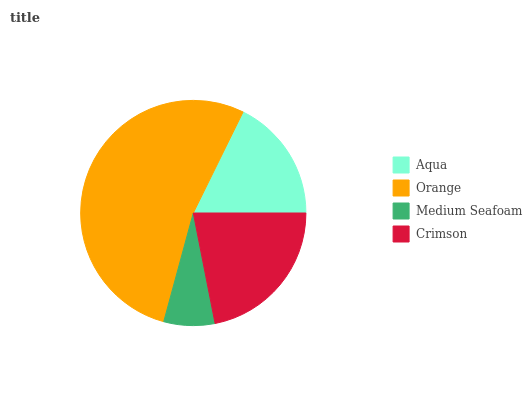Is Medium Seafoam the minimum?
Answer yes or no. Yes. Is Orange the maximum?
Answer yes or no. Yes. Is Orange the minimum?
Answer yes or no. No. Is Medium Seafoam the maximum?
Answer yes or no. No. Is Orange greater than Medium Seafoam?
Answer yes or no. Yes. Is Medium Seafoam less than Orange?
Answer yes or no. Yes. Is Medium Seafoam greater than Orange?
Answer yes or no. No. Is Orange less than Medium Seafoam?
Answer yes or no. No. Is Crimson the high median?
Answer yes or no. Yes. Is Aqua the low median?
Answer yes or no. Yes. Is Orange the high median?
Answer yes or no. No. Is Crimson the low median?
Answer yes or no. No. 